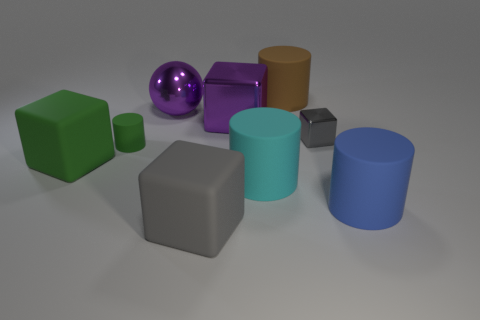What number of other things are the same size as the metal sphere?
Ensure brevity in your answer.  6. How many other objects are the same color as the tiny rubber object?
Your response must be concise. 1. What number of other things are there of the same shape as the large green rubber thing?
Provide a succinct answer. 3. Do the green rubber cylinder and the cyan matte thing have the same size?
Provide a succinct answer. No. Are any large brown matte cylinders visible?
Make the answer very short. Yes. Is there a large cyan cylinder made of the same material as the tiny green thing?
Provide a succinct answer. Yes. What material is the brown thing that is the same size as the purple block?
Provide a succinct answer. Rubber. How many big blue matte objects are the same shape as the small green thing?
Give a very brief answer. 1. What size is the blue cylinder that is the same material as the small green object?
Provide a succinct answer. Large. What is the object that is both left of the big purple metal sphere and on the right side of the big green block made of?
Provide a short and direct response. Rubber. 